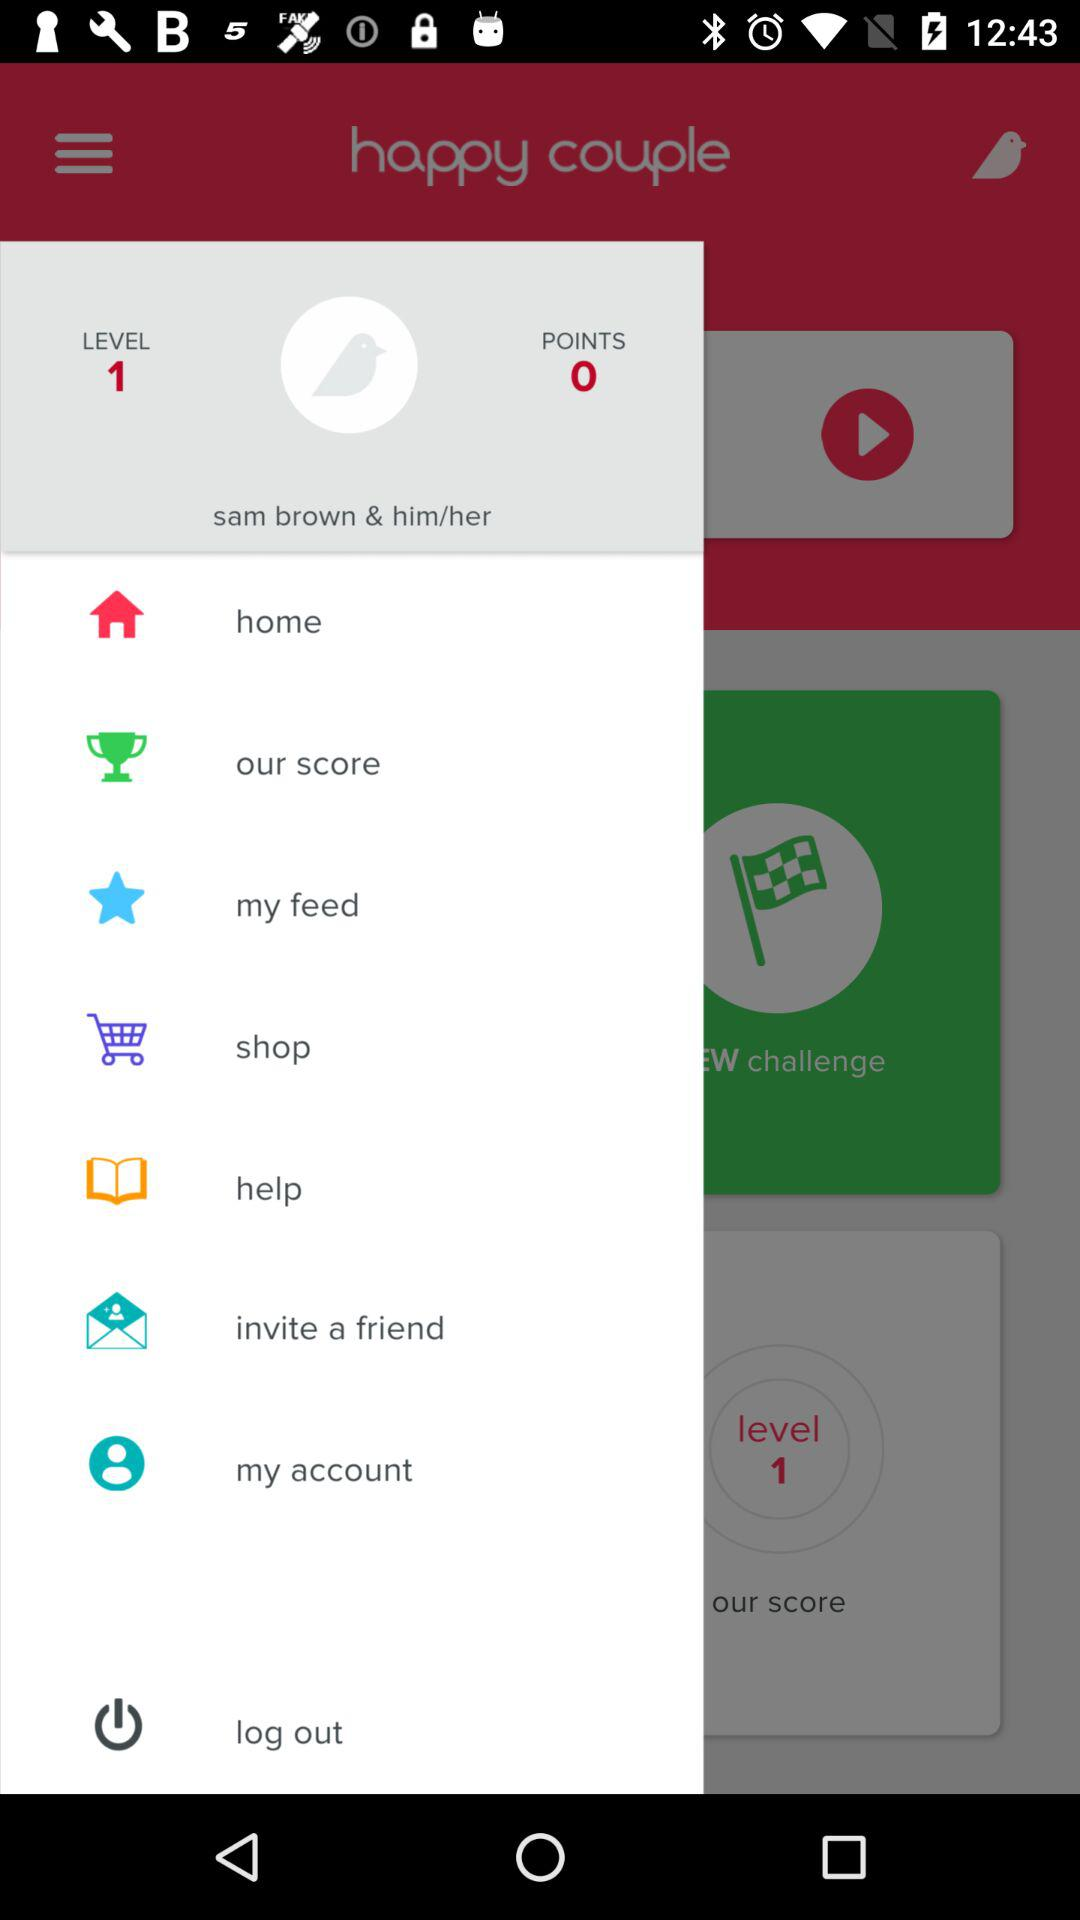At what level is the user? The user is at level 1. 